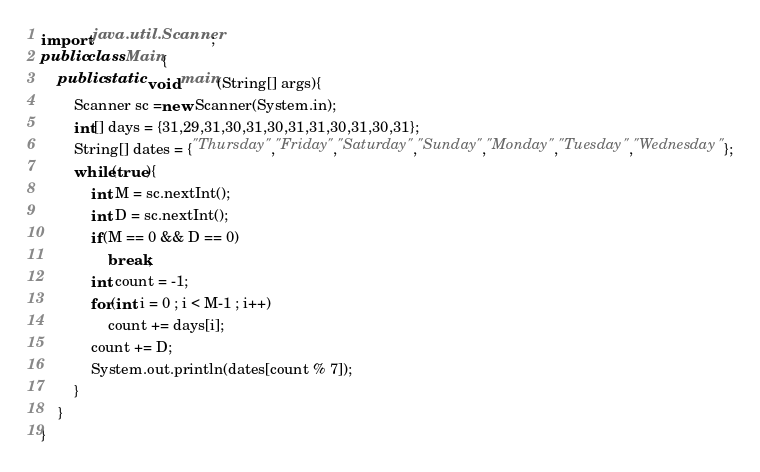Convert code to text. <code><loc_0><loc_0><loc_500><loc_500><_Java_>import java.util.Scanner;
public class Main{
    public static void main(String[] args){
        Scanner sc =new Scanner(System.in);
        int[] days = {31,29,31,30,31,30,31,31,30,31,30,31};
        String[] dates = {"Thursday","Friday","Saturday","Sunday","Monday","Tuesday","Wednesday"};
        while(true){
            int M = sc.nextInt();
            int D = sc.nextInt();
            if(M == 0 && D == 0)
                break;
            int count = -1;
            for(int i = 0 ; i < M-1 ; i++)
                count += days[i];
            count += D;
            System.out.println(dates[count % 7]);
        }
    }
}
</code> 